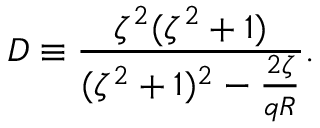Convert formula to latex. <formula><loc_0><loc_0><loc_500><loc_500>D \equiv \frac { \zeta ^ { 2 } ( \zeta ^ { 2 } + 1 ) } { ( \zeta ^ { 2 } + 1 ) ^ { 2 } - \frac { 2 \zeta } { q R } } .</formula> 